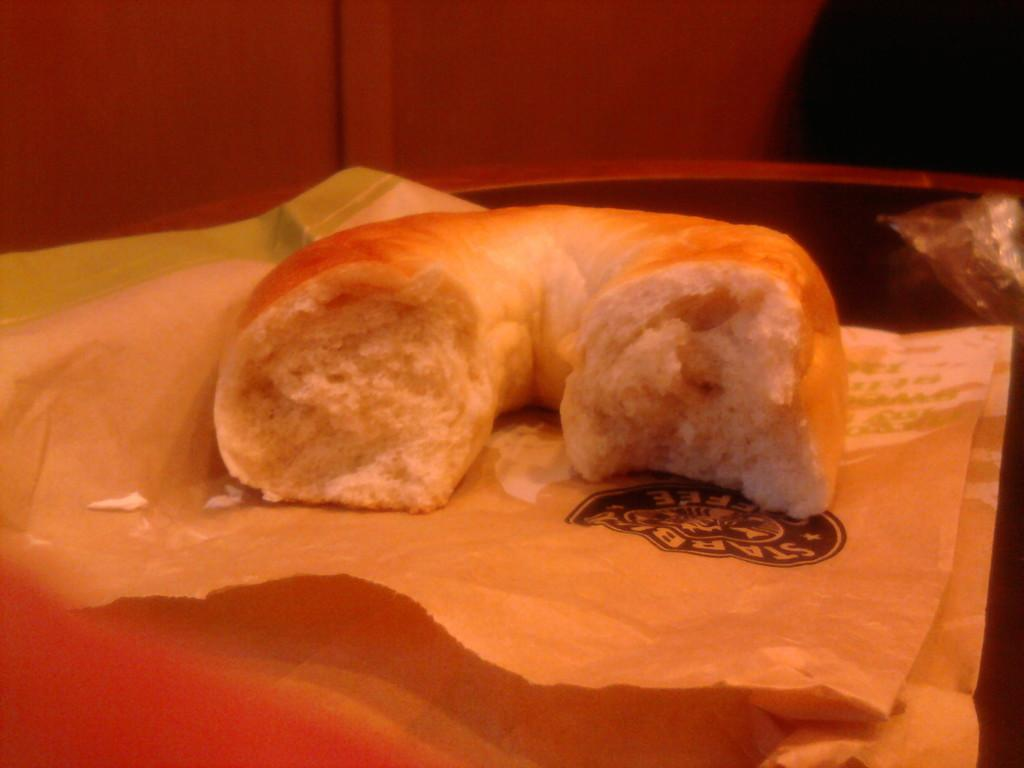What is the state of the food item in the image? The food item is half-eaten in the image. What is the food item placed on? The food item is on a paper. Where is the paper with the food item located? The paper is placed on a table. What can be seen in the background of the image? There is a wall in the background of the image. What is the reaction of the unit to the shape of the food item in the image? There is no unit or shape mentioned in the image, so it is not possible to answer this question. 